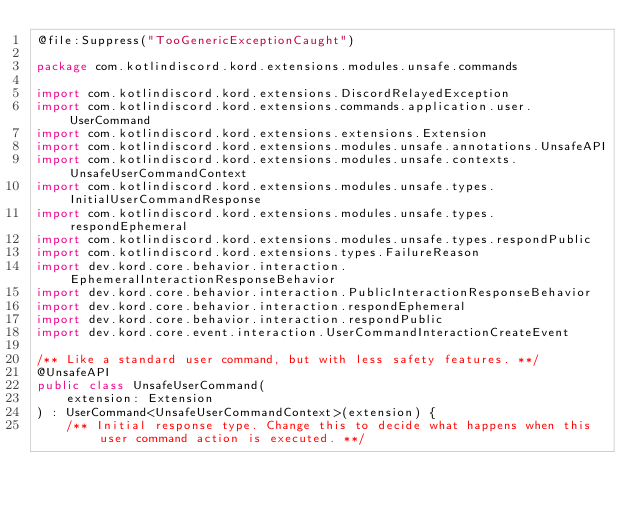<code> <loc_0><loc_0><loc_500><loc_500><_Kotlin_>@file:Suppress("TooGenericExceptionCaught")

package com.kotlindiscord.kord.extensions.modules.unsafe.commands

import com.kotlindiscord.kord.extensions.DiscordRelayedException
import com.kotlindiscord.kord.extensions.commands.application.user.UserCommand
import com.kotlindiscord.kord.extensions.extensions.Extension
import com.kotlindiscord.kord.extensions.modules.unsafe.annotations.UnsafeAPI
import com.kotlindiscord.kord.extensions.modules.unsafe.contexts.UnsafeUserCommandContext
import com.kotlindiscord.kord.extensions.modules.unsafe.types.InitialUserCommandResponse
import com.kotlindiscord.kord.extensions.modules.unsafe.types.respondEphemeral
import com.kotlindiscord.kord.extensions.modules.unsafe.types.respondPublic
import com.kotlindiscord.kord.extensions.types.FailureReason
import dev.kord.core.behavior.interaction.EphemeralInteractionResponseBehavior
import dev.kord.core.behavior.interaction.PublicInteractionResponseBehavior
import dev.kord.core.behavior.interaction.respondEphemeral
import dev.kord.core.behavior.interaction.respondPublic
import dev.kord.core.event.interaction.UserCommandInteractionCreateEvent

/** Like a standard user command, but with less safety features. **/
@UnsafeAPI
public class UnsafeUserCommand(
    extension: Extension
) : UserCommand<UnsafeUserCommandContext>(extension) {
    /** Initial response type. Change this to decide what happens when this user command action is executed. **/</code> 